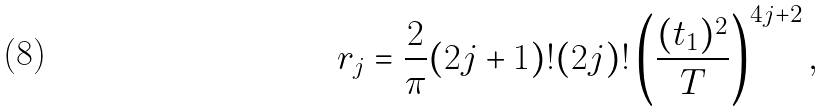<formula> <loc_0><loc_0><loc_500><loc_500>r _ { j } = \frac { 2 } { \pi } ( 2 j + 1 ) ! ( 2 j ) ! \left ( \frac { ( t _ { 1 } ) ^ { 2 } } { T } \right ) ^ { 4 j + 2 } ,</formula> 